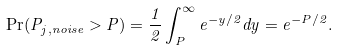Convert formula to latex. <formula><loc_0><loc_0><loc_500><loc_500>\Pr ( P _ { j , n o i s e } > P ) = \frac { 1 } { 2 } \int _ { P } ^ { \infty } e ^ { - y / 2 } d y = e ^ { - P / 2 } .</formula> 